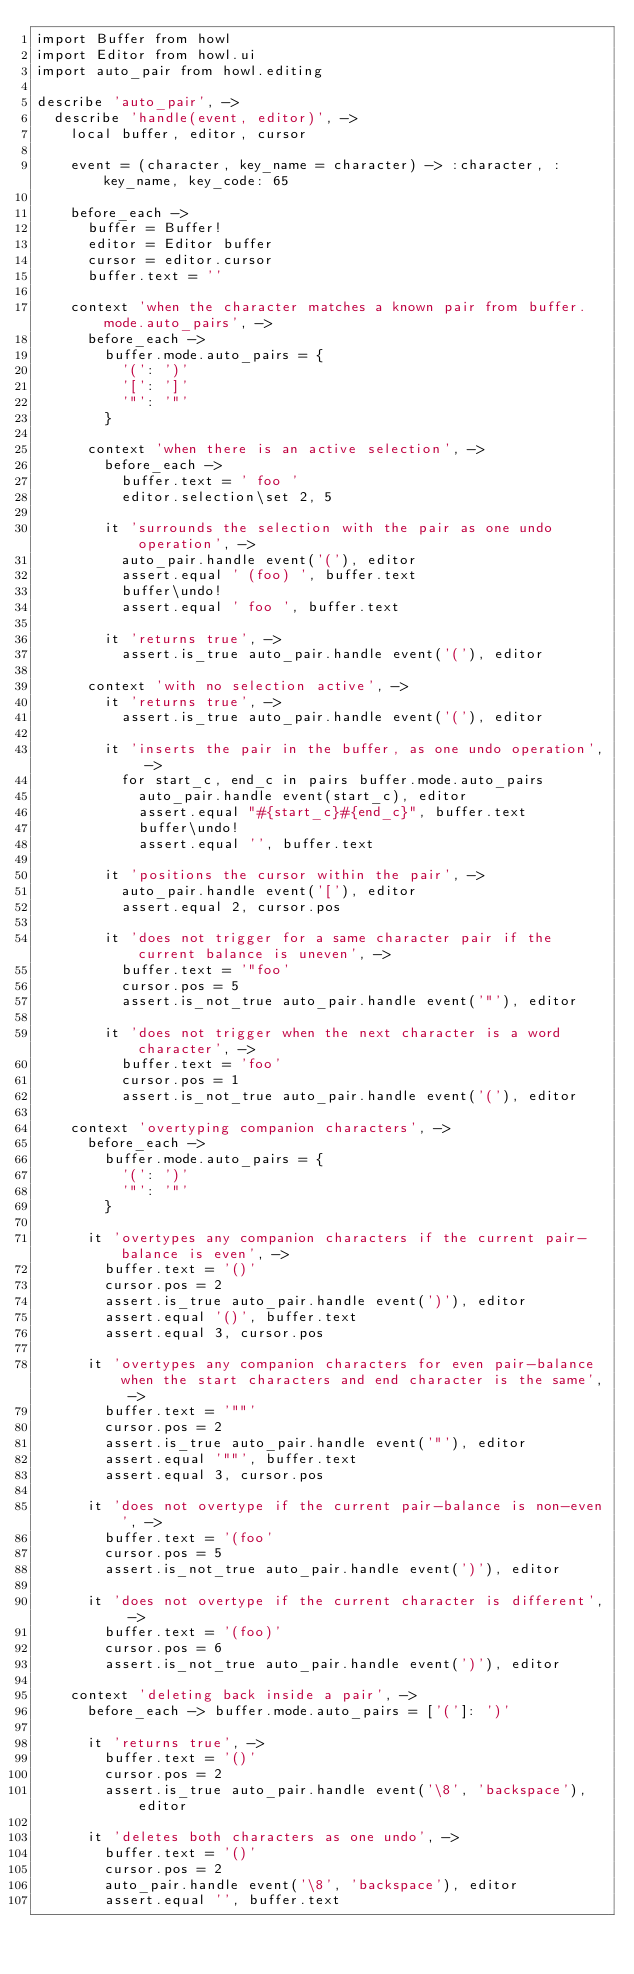<code> <loc_0><loc_0><loc_500><loc_500><_MoonScript_>import Buffer from howl
import Editor from howl.ui
import auto_pair from howl.editing

describe 'auto_pair', ->
  describe 'handle(event, editor)', ->
    local buffer, editor, cursor

    event = (character, key_name = character) -> :character, :key_name, key_code: 65

    before_each ->
      buffer = Buffer!
      editor = Editor buffer
      cursor = editor.cursor
      buffer.text = ''

    context 'when the character matches a known pair from buffer.mode.auto_pairs', ->
      before_each ->
        buffer.mode.auto_pairs = {
          '(': ')'
          '[': ']'
          '"': '"'
        }

      context 'when there is an active selection', ->
        before_each ->
          buffer.text = ' foo '
          editor.selection\set 2, 5

        it 'surrounds the selection with the pair as one undo operation', ->
          auto_pair.handle event('('), editor
          assert.equal ' (foo) ', buffer.text
          buffer\undo!
          assert.equal ' foo ', buffer.text

        it 'returns true', ->
          assert.is_true auto_pair.handle event('('), editor

      context 'with no selection active', ->
        it 'returns true', ->
          assert.is_true auto_pair.handle event('('), editor

        it 'inserts the pair in the buffer, as one undo operation', ->
          for start_c, end_c in pairs buffer.mode.auto_pairs
            auto_pair.handle event(start_c), editor
            assert.equal "#{start_c}#{end_c}", buffer.text
            buffer\undo!
            assert.equal '', buffer.text

        it 'positions the cursor within the pair', ->
          auto_pair.handle event('['), editor
          assert.equal 2, cursor.pos

        it 'does not trigger for a same character pair if the current balance is uneven', ->
          buffer.text = '"foo'
          cursor.pos = 5
          assert.is_not_true auto_pair.handle event('"'), editor

        it 'does not trigger when the next character is a word character', ->
          buffer.text = 'foo'
          cursor.pos = 1
          assert.is_not_true auto_pair.handle event('('), editor

    context 'overtyping companion characters', ->
      before_each ->
        buffer.mode.auto_pairs = {
          '(': ')'
          '"': '"'
        }

      it 'overtypes any companion characters if the current pair-balance is even', ->
        buffer.text = '()'
        cursor.pos = 2
        assert.is_true auto_pair.handle event(')'), editor
        assert.equal '()', buffer.text
        assert.equal 3, cursor.pos

      it 'overtypes any companion characters for even pair-balance when the start characters and end character is the same', ->
        buffer.text = '""'
        cursor.pos = 2
        assert.is_true auto_pair.handle event('"'), editor
        assert.equal '""', buffer.text
        assert.equal 3, cursor.pos

      it 'does not overtype if the current pair-balance is non-even', ->
        buffer.text = '(foo'
        cursor.pos = 5
        assert.is_not_true auto_pair.handle event(')'), editor

      it 'does not overtype if the current character is different', ->
        buffer.text = '(foo)'
        cursor.pos = 6
        assert.is_not_true auto_pair.handle event(')'), editor

    context 'deleting back inside a pair', ->
      before_each -> buffer.mode.auto_pairs = ['(']: ')'

      it 'returns true', ->
        buffer.text = '()'
        cursor.pos = 2
        assert.is_true auto_pair.handle event('\8', 'backspace'), editor

      it 'deletes both characters as one undo', ->
        buffer.text = '()'
        cursor.pos = 2
        auto_pair.handle event('\8', 'backspace'), editor
        assert.equal '', buffer.text</code> 